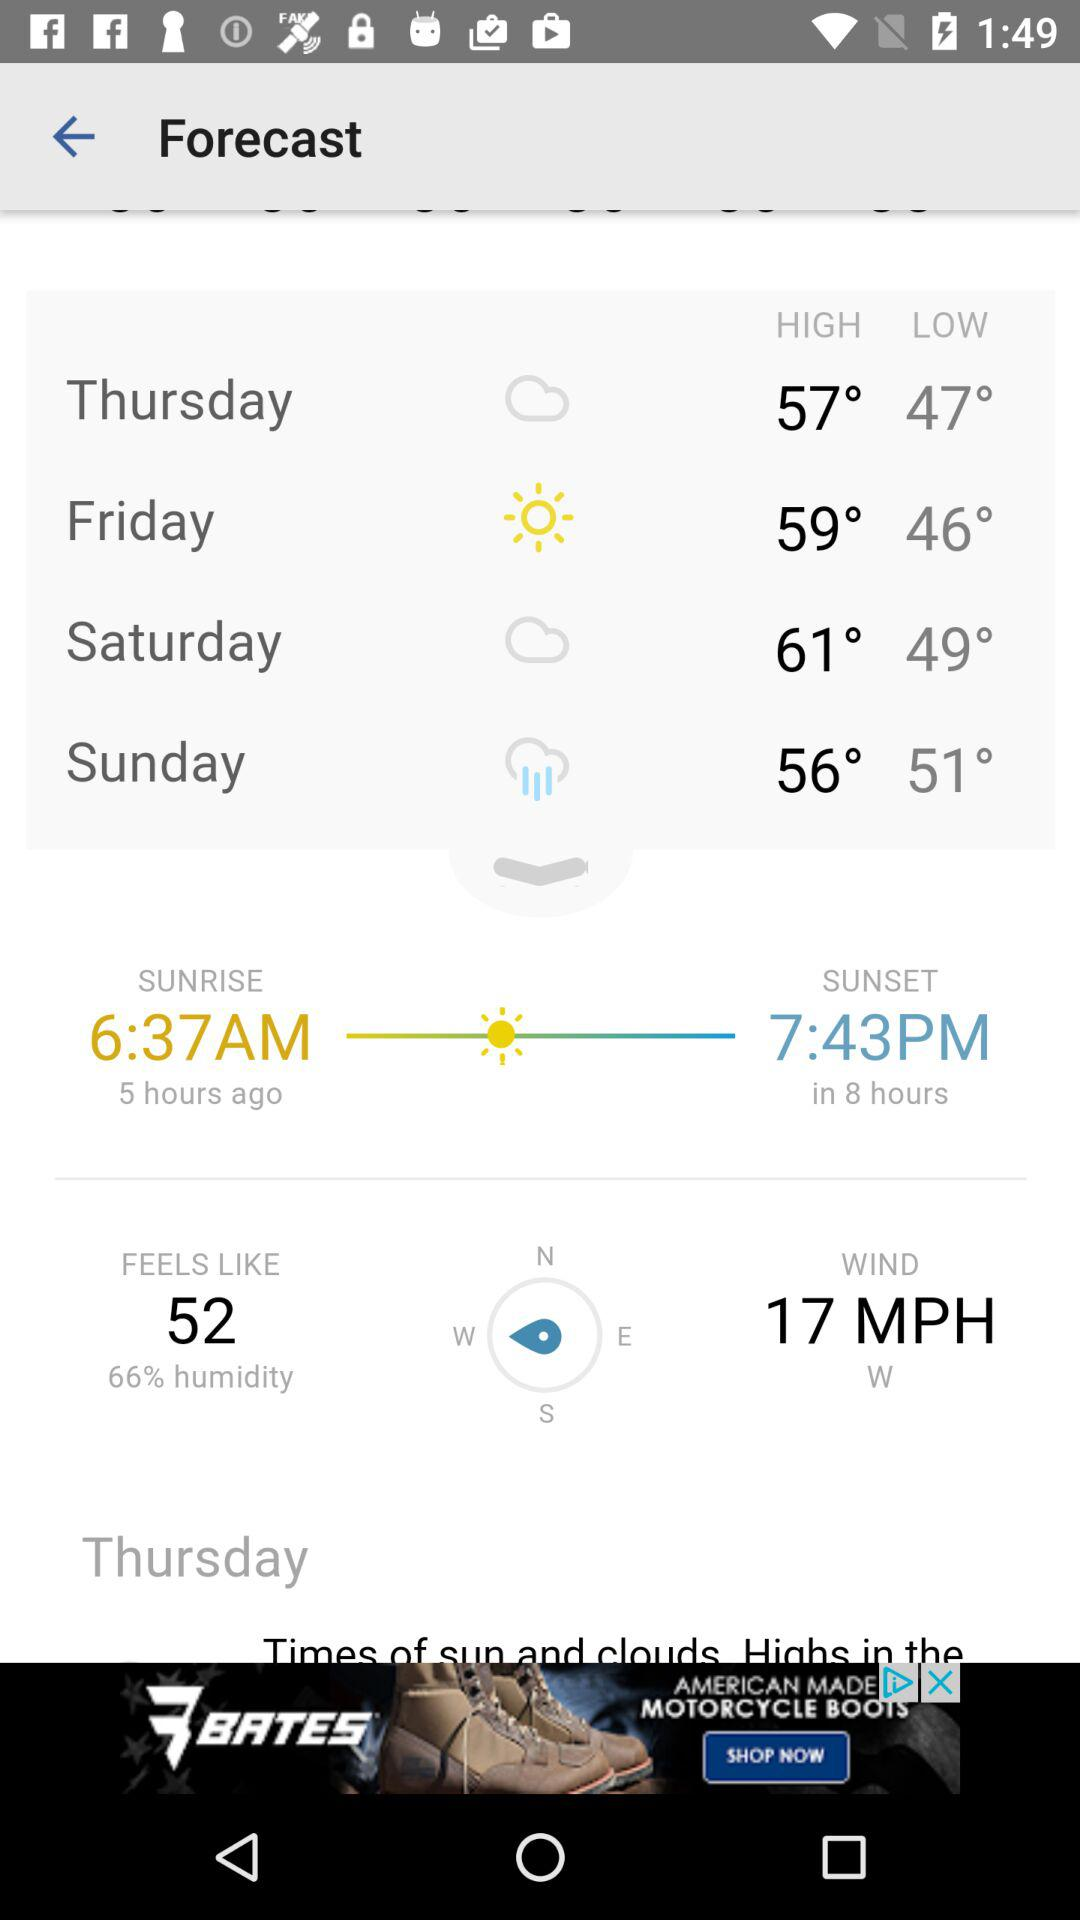What is the humidity percentage? The humidity percentage is 66. 